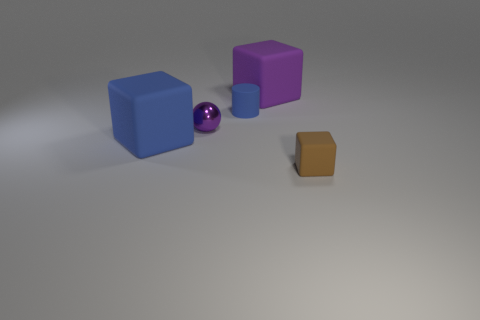What shape is the large rubber object that is the same color as the cylinder?
Make the answer very short. Cube. Are there any big blue matte objects of the same shape as the small brown matte thing?
Give a very brief answer. Yes. The purple thing that is the same size as the cylinder is what shape?
Keep it short and to the point. Sphere. Do the tiny ball and the rubber cube that is behind the blue rubber block have the same color?
Your answer should be compact. Yes. What number of tiny blue cylinders are on the right side of the blue matte thing that is in front of the tiny blue cylinder?
Give a very brief answer. 1. What size is the object that is both behind the big blue thing and to the right of the small blue rubber thing?
Offer a terse response. Large. Is there a brown thing that has the same size as the blue matte cylinder?
Your answer should be compact. Yes. Is the number of purple matte cubes that are to the left of the brown block greater than the number of tiny rubber blocks that are behind the blue block?
Ensure brevity in your answer.  Yes. Does the small cylinder have the same material as the large thing on the right side of the small purple sphere?
Provide a short and direct response. Yes. What number of blue blocks are right of the block on the left side of the cube behind the sphere?
Provide a short and direct response. 0. 